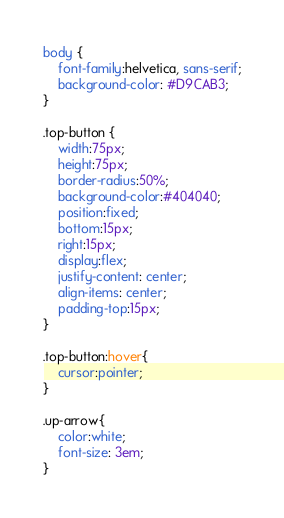<code> <loc_0><loc_0><loc_500><loc_500><_CSS_>body {
    font-family:helvetica, sans-serif;
    background-color: #D9CAB3;
}

.top-button {
	width:75px;
	height:75px;
	border-radius:50%;
	background-color:#404040;
	position:fixed;
	bottom:15px;
	right:15px;
	display:flex;
	justify-content: center;
	align-items: center;
	padding-top:15px;
}

.top-button:hover{
	cursor:pointer;
}

.up-arrow{
	color:white;
	font-size: 3em;
}
</code> 